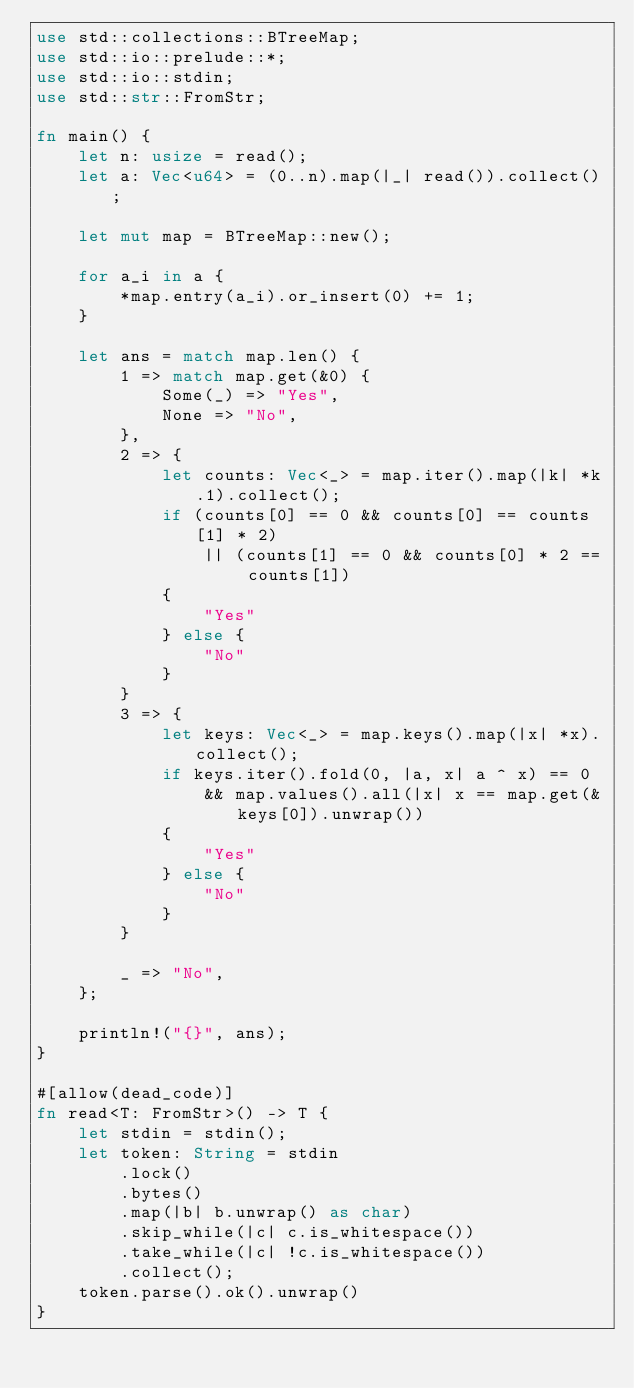<code> <loc_0><loc_0><loc_500><loc_500><_Rust_>use std::collections::BTreeMap;
use std::io::prelude::*;
use std::io::stdin;
use std::str::FromStr;

fn main() {
    let n: usize = read();
    let a: Vec<u64> = (0..n).map(|_| read()).collect();

    let mut map = BTreeMap::new();

    for a_i in a {
        *map.entry(a_i).or_insert(0) += 1;
    }

    let ans = match map.len() {
        1 => match map.get(&0) {
            Some(_) => "Yes",
            None => "No",
        },
        2 => {
            let counts: Vec<_> = map.iter().map(|k| *k.1).collect();
            if (counts[0] == 0 && counts[0] == counts[1] * 2)
                || (counts[1] == 0 && counts[0] * 2 == counts[1])
            {
                "Yes"
            } else {
                "No"
            }
        }
        3 => {
            let keys: Vec<_> = map.keys().map(|x| *x).collect();
            if keys.iter().fold(0, |a, x| a ^ x) == 0
                && map.values().all(|x| x == map.get(&keys[0]).unwrap())
            {
                "Yes"
            } else {
                "No"
            }
        }

        _ => "No",
    };

    println!("{}", ans);
}

#[allow(dead_code)]
fn read<T: FromStr>() -> T {
    let stdin = stdin();
    let token: String = stdin
        .lock()
        .bytes()
        .map(|b| b.unwrap() as char)
        .skip_while(|c| c.is_whitespace())
        .take_while(|c| !c.is_whitespace())
        .collect();
    token.parse().ok().unwrap()
}
</code> 